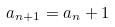<formula> <loc_0><loc_0><loc_500><loc_500>a _ { n + 1 } = a _ { n } + 1</formula> 